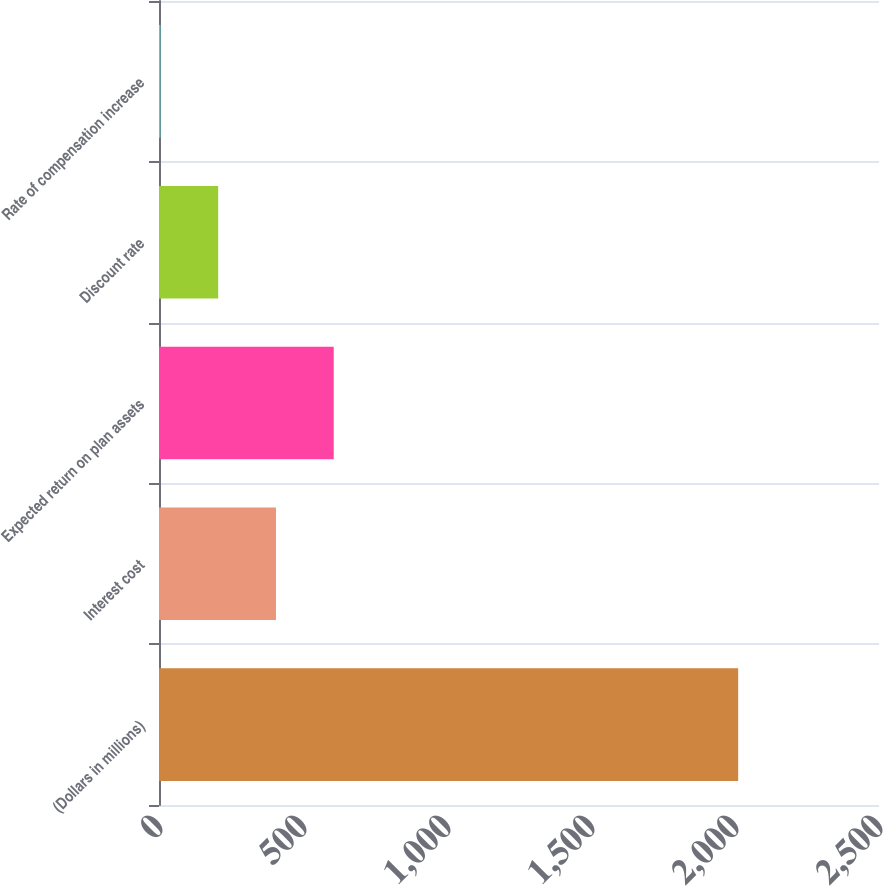<chart> <loc_0><loc_0><loc_500><loc_500><bar_chart><fcel>(Dollars in millions)<fcel>Interest cost<fcel>Expected return on plan assets<fcel>Discount rate<fcel>Rate of compensation increase<nl><fcel>2011<fcel>406.09<fcel>606.7<fcel>205.47<fcel>4.85<nl></chart> 